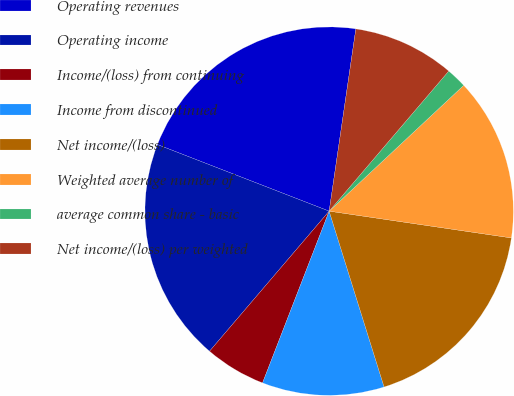<chart> <loc_0><loc_0><loc_500><loc_500><pie_chart><fcel>Operating revenues<fcel>Operating income<fcel>Income/(loss) from continuing<fcel>Income from discontinued<fcel>Net income/(loss)<fcel>Weighted average number of<fcel>average common share - basic<fcel>Net income/(loss) per weighted<nl><fcel>21.43%<fcel>19.64%<fcel>5.36%<fcel>10.71%<fcel>17.86%<fcel>14.29%<fcel>1.79%<fcel>8.93%<nl></chart> 